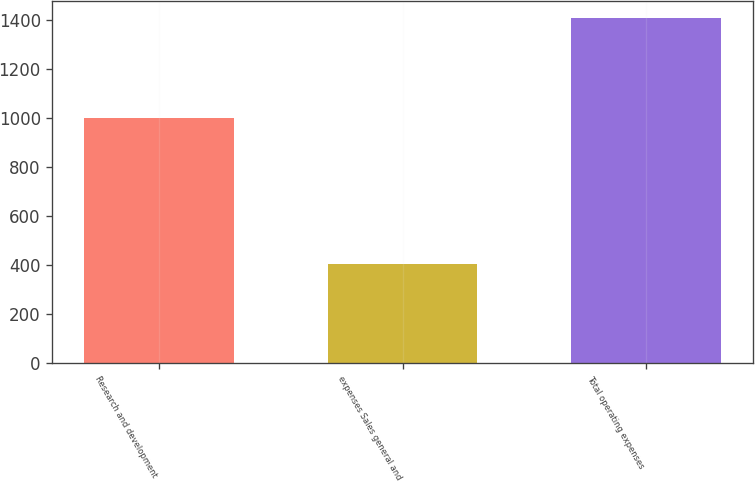<chart> <loc_0><loc_0><loc_500><loc_500><bar_chart><fcel>Research and development<fcel>expenses Sales general and<fcel>Total operating expenses<nl><fcel>1002.6<fcel>405.6<fcel>1408.2<nl></chart> 